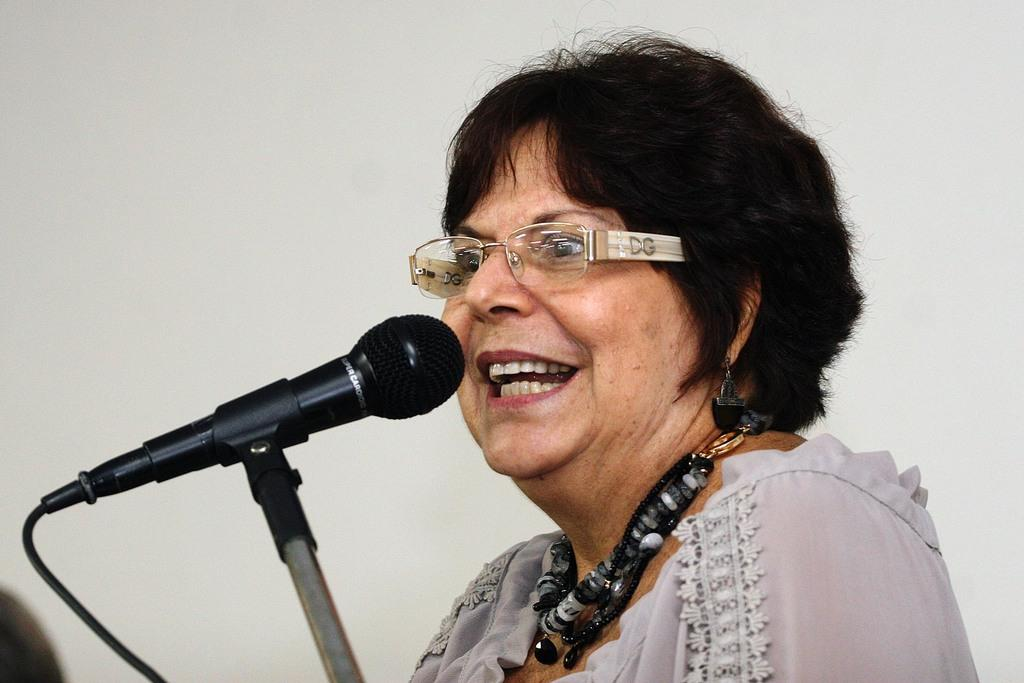What is the main subject of the image? The main subject of the image is a lady person. What is the lady person wearing? The lady person is wearing a white dress and spectacles. What type of accessory is the lady person wearing around her neck? The lady person is wearing a black color necklace. What is the lady person's posture in the image? The lady person is standing in the image. What object is in front of the lady person? There is a microphone in front of the lady person. How much wealth is displayed by the lady person in the image? There is no indication of wealth in the image; it only shows the lady person wearing a white dress, spectacles, and a black necklace, standing with a microphone in front of her. What type of tooth can be seen in the lady person's mouth in the image? There is no tooth visible in the image; it only shows the lady person's face from the eyes up, wearing spectacles. 